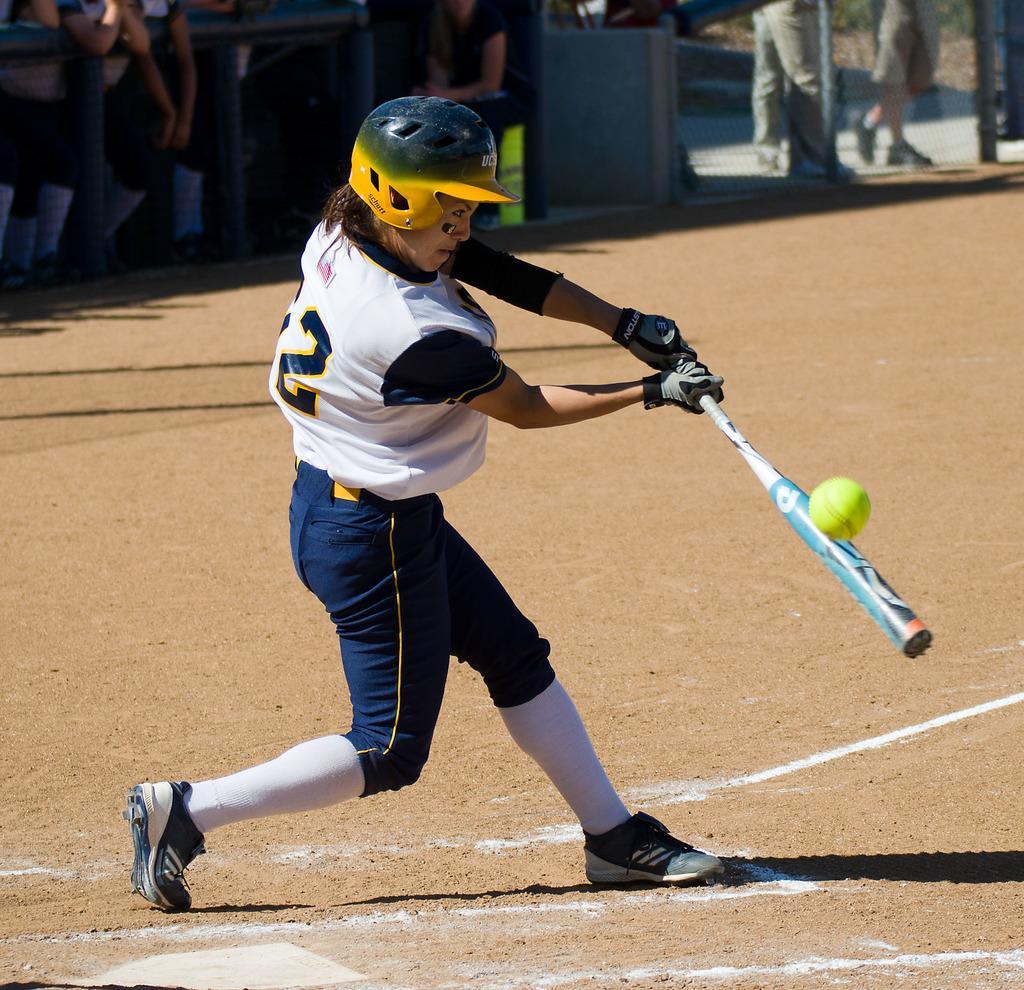How would you summarize this image in a sentence or two? In this image I can see a person holding a bat and wearing different color dress. We can see a ball. Back Side I can see few people. 